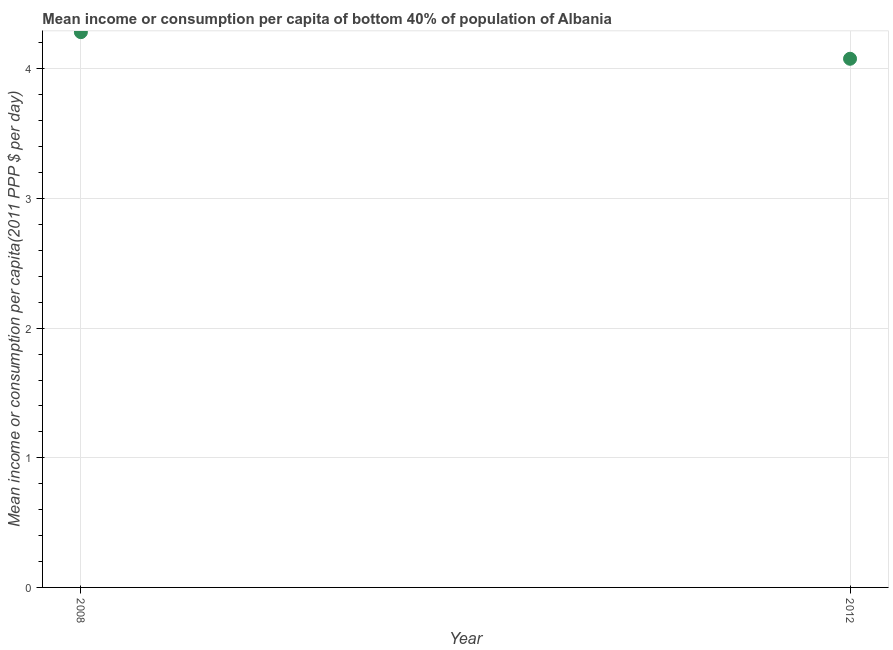What is the mean income or consumption in 2012?
Offer a very short reply. 4.08. Across all years, what is the maximum mean income or consumption?
Provide a short and direct response. 4.28. Across all years, what is the minimum mean income or consumption?
Offer a very short reply. 4.08. In which year was the mean income or consumption maximum?
Your answer should be compact. 2008. What is the sum of the mean income or consumption?
Your response must be concise. 8.36. What is the difference between the mean income or consumption in 2008 and 2012?
Provide a short and direct response. 0.21. What is the average mean income or consumption per year?
Your response must be concise. 4.18. What is the median mean income or consumption?
Make the answer very short. 4.18. In how many years, is the mean income or consumption greater than 1 $?
Make the answer very short. 2. Do a majority of the years between 2012 and 2008 (inclusive) have mean income or consumption greater than 4 $?
Make the answer very short. No. What is the ratio of the mean income or consumption in 2008 to that in 2012?
Offer a terse response. 1.05. Is the mean income or consumption in 2008 less than that in 2012?
Provide a succinct answer. No. Does the mean income or consumption monotonically increase over the years?
Your answer should be very brief. No. How many years are there in the graph?
Give a very brief answer. 2. What is the difference between two consecutive major ticks on the Y-axis?
Give a very brief answer. 1. Does the graph contain grids?
Offer a terse response. Yes. What is the title of the graph?
Your response must be concise. Mean income or consumption per capita of bottom 40% of population of Albania. What is the label or title of the X-axis?
Offer a terse response. Year. What is the label or title of the Y-axis?
Offer a terse response. Mean income or consumption per capita(2011 PPP $ per day). What is the Mean income or consumption per capita(2011 PPP $ per day) in 2008?
Provide a short and direct response. 4.28. What is the Mean income or consumption per capita(2011 PPP $ per day) in 2012?
Ensure brevity in your answer.  4.08. What is the difference between the Mean income or consumption per capita(2011 PPP $ per day) in 2008 and 2012?
Provide a succinct answer. 0.21. 